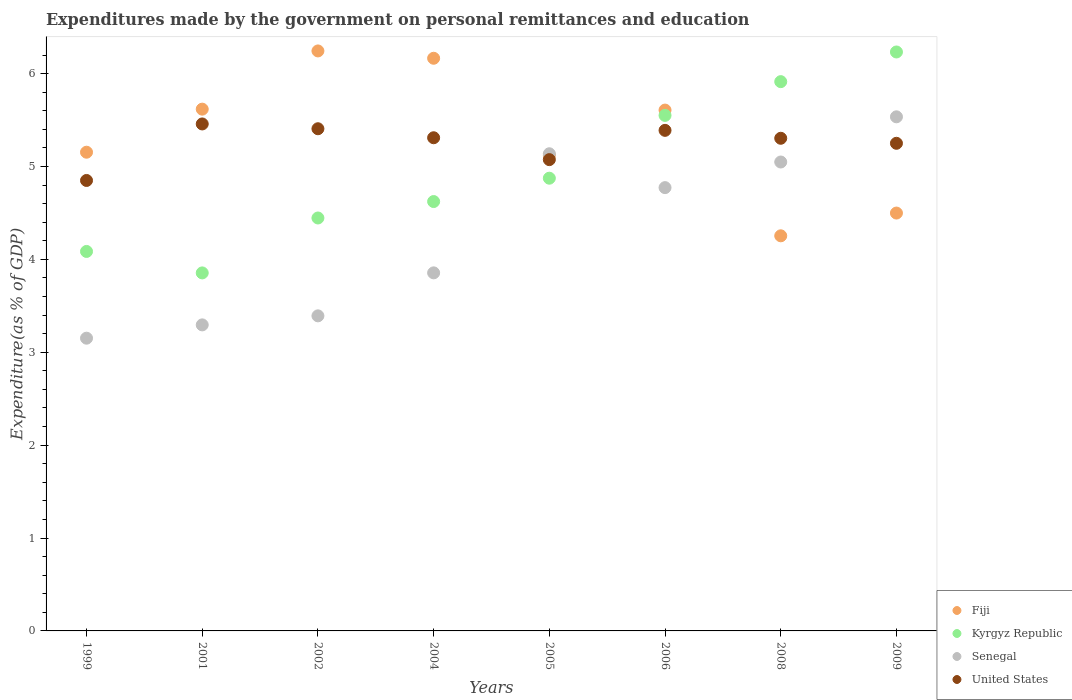What is the expenditures made by the government on personal remittances and education in Senegal in 2005?
Keep it short and to the point. 5.14. Across all years, what is the maximum expenditures made by the government on personal remittances and education in Fiji?
Provide a short and direct response. 6.24. Across all years, what is the minimum expenditures made by the government on personal remittances and education in Fiji?
Offer a terse response. 4.25. In which year was the expenditures made by the government on personal remittances and education in Fiji maximum?
Offer a very short reply. 2002. In which year was the expenditures made by the government on personal remittances and education in United States minimum?
Your answer should be compact. 1999. What is the total expenditures made by the government on personal remittances and education in Kyrgyz Republic in the graph?
Ensure brevity in your answer.  39.58. What is the difference between the expenditures made by the government on personal remittances and education in Senegal in 2004 and that in 2005?
Offer a terse response. -1.28. What is the difference between the expenditures made by the government on personal remittances and education in Senegal in 2002 and the expenditures made by the government on personal remittances and education in Fiji in 2008?
Provide a short and direct response. -0.86. What is the average expenditures made by the government on personal remittances and education in Senegal per year?
Your answer should be compact. 4.27. In the year 2008, what is the difference between the expenditures made by the government on personal remittances and education in Kyrgyz Republic and expenditures made by the government on personal remittances and education in United States?
Offer a very short reply. 0.61. What is the ratio of the expenditures made by the government on personal remittances and education in Senegal in 2001 to that in 2005?
Offer a terse response. 0.64. Is the expenditures made by the government on personal remittances and education in Kyrgyz Republic in 2004 less than that in 2005?
Make the answer very short. Yes. Is the difference between the expenditures made by the government on personal remittances and education in Kyrgyz Republic in 2001 and 2008 greater than the difference between the expenditures made by the government on personal remittances and education in United States in 2001 and 2008?
Provide a short and direct response. No. What is the difference between the highest and the second highest expenditures made by the government on personal remittances and education in Fiji?
Ensure brevity in your answer.  0.08. What is the difference between the highest and the lowest expenditures made by the government on personal remittances and education in Senegal?
Offer a very short reply. 2.38. Is it the case that in every year, the sum of the expenditures made by the government on personal remittances and education in United States and expenditures made by the government on personal remittances and education in Fiji  is greater than the sum of expenditures made by the government on personal remittances and education in Kyrgyz Republic and expenditures made by the government on personal remittances and education in Senegal?
Ensure brevity in your answer.  No. Is it the case that in every year, the sum of the expenditures made by the government on personal remittances and education in Fiji and expenditures made by the government on personal remittances and education in Senegal  is greater than the expenditures made by the government on personal remittances and education in Kyrgyz Republic?
Provide a short and direct response. Yes. Does the expenditures made by the government on personal remittances and education in United States monotonically increase over the years?
Make the answer very short. No. Is the expenditures made by the government on personal remittances and education in Kyrgyz Republic strictly greater than the expenditures made by the government on personal remittances and education in United States over the years?
Your response must be concise. No. Is the expenditures made by the government on personal remittances and education in Senegal strictly less than the expenditures made by the government on personal remittances and education in Fiji over the years?
Provide a succinct answer. No. Are the values on the major ticks of Y-axis written in scientific E-notation?
Provide a succinct answer. No. Does the graph contain any zero values?
Make the answer very short. No. Does the graph contain grids?
Your answer should be very brief. No. What is the title of the graph?
Ensure brevity in your answer.  Expenditures made by the government on personal remittances and education. What is the label or title of the Y-axis?
Provide a succinct answer. Expenditure(as % of GDP). What is the Expenditure(as % of GDP) of Fiji in 1999?
Keep it short and to the point. 5.15. What is the Expenditure(as % of GDP) in Kyrgyz Republic in 1999?
Your answer should be very brief. 4.09. What is the Expenditure(as % of GDP) in Senegal in 1999?
Ensure brevity in your answer.  3.15. What is the Expenditure(as % of GDP) of United States in 1999?
Offer a very short reply. 4.85. What is the Expenditure(as % of GDP) in Fiji in 2001?
Your answer should be compact. 5.62. What is the Expenditure(as % of GDP) in Kyrgyz Republic in 2001?
Provide a succinct answer. 3.85. What is the Expenditure(as % of GDP) of Senegal in 2001?
Provide a short and direct response. 3.29. What is the Expenditure(as % of GDP) of United States in 2001?
Keep it short and to the point. 5.46. What is the Expenditure(as % of GDP) in Fiji in 2002?
Ensure brevity in your answer.  6.24. What is the Expenditure(as % of GDP) in Kyrgyz Republic in 2002?
Your answer should be very brief. 4.45. What is the Expenditure(as % of GDP) in Senegal in 2002?
Provide a succinct answer. 3.39. What is the Expenditure(as % of GDP) in United States in 2002?
Provide a succinct answer. 5.41. What is the Expenditure(as % of GDP) of Fiji in 2004?
Offer a very short reply. 6.16. What is the Expenditure(as % of GDP) in Kyrgyz Republic in 2004?
Offer a terse response. 4.62. What is the Expenditure(as % of GDP) in Senegal in 2004?
Make the answer very short. 3.85. What is the Expenditure(as % of GDP) in United States in 2004?
Offer a very short reply. 5.31. What is the Expenditure(as % of GDP) in Fiji in 2005?
Provide a succinct answer. 5.12. What is the Expenditure(as % of GDP) in Kyrgyz Republic in 2005?
Your answer should be very brief. 4.87. What is the Expenditure(as % of GDP) in Senegal in 2005?
Provide a short and direct response. 5.14. What is the Expenditure(as % of GDP) of United States in 2005?
Offer a very short reply. 5.07. What is the Expenditure(as % of GDP) of Fiji in 2006?
Offer a terse response. 5.61. What is the Expenditure(as % of GDP) in Kyrgyz Republic in 2006?
Your response must be concise. 5.55. What is the Expenditure(as % of GDP) in Senegal in 2006?
Keep it short and to the point. 4.77. What is the Expenditure(as % of GDP) in United States in 2006?
Offer a terse response. 5.39. What is the Expenditure(as % of GDP) in Fiji in 2008?
Give a very brief answer. 4.25. What is the Expenditure(as % of GDP) in Kyrgyz Republic in 2008?
Offer a very short reply. 5.91. What is the Expenditure(as % of GDP) in Senegal in 2008?
Provide a short and direct response. 5.05. What is the Expenditure(as % of GDP) of United States in 2008?
Keep it short and to the point. 5.3. What is the Expenditure(as % of GDP) of Fiji in 2009?
Provide a short and direct response. 4.5. What is the Expenditure(as % of GDP) in Kyrgyz Republic in 2009?
Keep it short and to the point. 6.23. What is the Expenditure(as % of GDP) of Senegal in 2009?
Offer a terse response. 5.53. What is the Expenditure(as % of GDP) of United States in 2009?
Your answer should be very brief. 5.25. Across all years, what is the maximum Expenditure(as % of GDP) in Fiji?
Provide a short and direct response. 6.24. Across all years, what is the maximum Expenditure(as % of GDP) in Kyrgyz Republic?
Keep it short and to the point. 6.23. Across all years, what is the maximum Expenditure(as % of GDP) in Senegal?
Keep it short and to the point. 5.53. Across all years, what is the maximum Expenditure(as % of GDP) in United States?
Offer a terse response. 5.46. Across all years, what is the minimum Expenditure(as % of GDP) in Fiji?
Offer a very short reply. 4.25. Across all years, what is the minimum Expenditure(as % of GDP) in Kyrgyz Republic?
Your response must be concise. 3.85. Across all years, what is the minimum Expenditure(as % of GDP) of Senegal?
Provide a succinct answer. 3.15. Across all years, what is the minimum Expenditure(as % of GDP) in United States?
Provide a succinct answer. 4.85. What is the total Expenditure(as % of GDP) in Fiji in the graph?
Provide a succinct answer. 42.66. What is the total Expenditure(as % of GDP) in Kyrgyz Republic in the graph?
Your answer should be very brief. 39.58. What is the total Expenditure(as % of GDP) of Senegal in the graph?
Your response must be concise. 34.18. What is the total Expenditure(as % of GDP) in United States in the graph?
Provide a succinct answer. 42.04. What is the difference between the Expenditure(as % of GDP) in Fiji in 1999 and that in 2001?
Your answer should be compact. -0.46. What is the difference between the Expenditure(as % of GDP) in Kyrgyz Republic in 1999 and that in 2001?
Provide a short and direct response. 0.23. What is the difference between the Expenditure(as % of GDP) of Senegal in 1999 and that in 2001?
Your answer should be compact. -0.14. What is the difference between the Expenditure(as % of GDP) in United States in 1999 and that in 2001?
Give a very brief answer. -0.61. What is the difference between the Expenditure(as % of GDP) of Fiji in 1999 and that in 2002?
Your response must be concise. -1.09. What is the difference between the Expenditure(as % of GDP) of Kyrgyz Republic in 1999 and that in 2002?
Give a very brief answer. -0.36. What is the difference between the Expenditure(as % of GDP) of Senegal in 1999 and that in 2002?
Your response must be concise. -0.24. What is the difference between the Expenditure(as % of GDP) of United States in 1999 and that in 2002?
Ensure brevity in your answer.  -0.56. What is the difference between the Expenditure(as % of GDP) in Fiji in 1999 and that in 2004?
Keep it short and to the point. -1.01. What is the difference between the Expenditure(as % of GDP) in Kyrgyz Republic in 1999 and that in 2004?
Make the answer very short. -0.54. What is the difference between the Expenditure(as % of GDP) of Senegal in 1999 and that in 2004?
Make the answer very short. -0.7. What is the difference between the Expenditure(as % of GDP) of United States in 1999 and that in 2004?
Your answer should be compact. -0.46. What is the difference between the Expenditure(as % of GDP) of Fiji in 1999 and that in 2005?
Provide a succinct answer. 0.03. What is the difference between the Expenditure(as % of GDP) of Kyrgyz Republic in 1999 and that in 2005?
Offer a very short reply. -0.79. What is the difference between the Expenditure(as % of GDP) of Senegal in 1999 and that in 2005?
Provide a short and direct response. -1.99. What is the difference between the Expenditure(as % of GDP) in United States in 1999 and that in 2005?
Your response must be concise. -0.22. What is the difference between the Expenditure(as % of GDP) in Fiji in 1999 and that in 2006?
Your answer should be very brief. -0.45. What is the difference between the Expenditure(as % of GDP) in Kyrgyz Republic in 1999 and that in 2006?
Make the answer very short. -1.46. What is the difference between the Expenditure(as % of GDP) of Senegal in 1999 and that in 2006?
Keep it short and to the point. -1.62. What is the difference between the Expenditure(as % of GDP) of United States in 1999 and that in 2006?
Make the answer very short. -0.54. What is the difference between the Expenditure(as % of GDP) in Fiji in 1999 and that in 2008?
Offer a terse response. 0.9. What is the difference between the Expenditure(as % of GDP) in Kyrgyz Republic in 1999 and that in 2008?
Ensure brevity in your answer.  -1.83. What is the difference between the Expenditure(as % of GDP) of Senegal in 1999 and that in 2008?
Provide a short and direct response. -1.9. What is the difference between the Expenditure(as % of GDP) in United States in 1999 and that in 2008?
Your answer should be very brief. -0.45. What is the difference between the Expenditure(as % of GDP) in Fiji in 1999 and that in 2009?
Ensure brevity in your answer.  0.66. What is the difference between the Expenditure(as % of GDP) in Kyrgyz Republic in 1999 and that in 2009?
Make the answer very short. -2.15. What is the difference between the Expenditure(as % of GDP) in Senegal in 1999 and that in 2009?
Provide a short and direct response. -2.38. What is the difference between the Expenditure(as % of GDP) of United States in 1999 and that in 2009?
Offer a terse response. -0.4. What is the difference between the Expenditure(as % of GDP) in Fiji in 2001 and that in 2002?
Your answer should be compact. -0.63. What is the difference between the Expenditure(as % of GDP) in Kyrgyz Republic in 2001 and that in 2002?
Keep it short and to the point. -0.59. What is the difference between the Expenditure(as % of GDP) of Senegal in 2001 and that in 2002?
Keep it short and to the point. -0.1. What is the difference between the Expenditure(as % of GDP) in United States in 2001 and that in 2002?
Keep it short and to the point. 0.05. What is the difference between the Expenditure(as % of GDP) in Fiji in 2001 and that in 2004?
Provide a short and direct response. -0.55. What is the difference between the Expenditure(as % of GDP) in Kyrgyz Republic in 2001 and that in 2004?
Provide a short and direct response. -0.77. What is the difference between the Expenditure(as % of GDP) of Senegal in 2001 and that in 2004?
Your response must be concise. -0.56. What is the difference between the Expenditure(as % of GDP) of United States in 2001 and that in 2004?
Make the answer very short. 0.15. What is the difference between the Expenditure(as % of GDP) in Fiji in 2001 and that in 2005?
Provide a short and direct response. 0.5. What is the difference between the Expenditure(as % of GDP) of Kyrgyz Republic in 2001 and that in 2005?
Your answer should be compact. -1.02. What is the difference between the Expenditure(as % of GDP) in Senegal in 2001 and that in 2005?
Offer a terse response. -1.84. What is the difference between the Expenditure(as % of GDP) of United States in 2001 and that in 2005?
Your response must be concise. 0.38. What is the difference between the Expenditure(as % of GDP) in Kyrgyz Republic in 2001 and that in 2006?
Provide a short and direct response. -1.7. What is the difference between the Expenditure(as % of GDP) in Senegal in 2001 and that in 2006?
Your response must be concise. -1.48. What is the difference between the Expenditure(as % of GDP) in United States in 2001 and that in 2006?
Ensure brevity in your answer.  0.07. What is the difference between the Expenditure(as % of GDP) of Fiji in 2001 and that in 2008?
Your answer should be compact. 1.36. What is the difference between the Expenditure(as % of GDP) in Kyrgyz Republic in 2001 and that in 2008?
Your answer should be very brief. -2.06. What is the difference between the Expenditure(as % of GDP) of Senegal in 2001 and that in 2008?
Give a very brief answer. -1.75. What is the difference between the Expenditure(as % of GDP) in United States in 2001 and that in 2008?
Make the answer very short. 0.15. What is the difference between the Expenditure(as % of GDP) of Fiji in 2001 and that in 2009?
Keep it short and to the point. 1.12. What is the difference between the Expenditure(as % of GDP) in Kyrgyz Republic in 2001 and that in 2009?
Your response must be concise. -2.38. What is the difference between the Expenditure(as % of GDP) in Senegal in 2001 and that in 2009?
Keep it short and to the point. -2.24. What is the difference between the Expenditure(as % of GDP) in United States in 2001 and that in 2009?
Offer a very short reply. 0.21. What is the difference between the Expenditure(as % of GDP) in Fiji in 2002 and that in 2004?
Make the answer very short. 0.08. What is the difference between the Expenditure(as % of GDP) in Kyrgyz Republic in 2002 and that in 2004?
Offer a very short reply. -0.18. What is the difference between the Expenditure(as % of GDP) in Senegal in 2002 and that in 2004?
Your answer should be compact. -0.46. What is the difference between the Expenditure(as % of GDP) in United States in 2002 and that in 2004?
Offer a terse response. 0.1. What is the difference between the Expenditure(as % of GDP) of Fiji in 2002 and that in 2005?
Make the answer very short. 1.12. What is the difference between the Expenditure(as % of GDP) in Kyrgyz Republic in 2002 and that in 2005?
Offer a very short reply. -0.43. What is the difference between the Expenditure(as % of GDP) in Senegal in 2002 and that in 2005?
Keep it short and to the point. -1.75. What is the difference between the Expenditure(as % of GDP) of United States in 2002 and that in 2005?
Give a very brief answer. 0.33. What is the difference between the Expenditure(as % of GDP) in Fiji in 2002 and that in 2006?
Give a very brief answer. 0.64. What is the difference between the Expenditure(as % of GDP) of Kyrgyz Republic in 2002 and that in 2006?
Keep it short and to the point. -1.1. What is the difference between the Expenditure(as % of GDP) of Senegal in 2002 and that in 2006?
Your answer should be very brief. -1.38. What is the difference between the Expenditure(as % of GDP) of United States in 2002 and that in 2006?
Your answer should be very brief. 0.02. What is the difference between the Expenditure(as % of GDP) in Fiji in 2002 and that in 2008?
Give a very brief answer. 1.99. What is the difference between the Expenditure(as % of GDP) of Kyrgyz Republic in 2002 and that in 2008?
Your answer should be compact. -1.47. What is the difference between the Expenditure(as % of GDP) of Senegal in 2002 and that in 2008?
Make the answer very short. -1.66. What is the difference between the Expenditure(as % of GDP) in United States in 2002 and that in 2008?
Keep it short and to the point. 0.1. What is the difference between the Expenditure(as % of GDP) in Fiji in 2002 and that in 2009?
Keep it short and to the point. 1.75. What is the difference between the Expenditure(as % of GDP) of Kyrgyz Republic in 2002 and that in 2009?
Offer a very short reply. -1.79. What is the difference between the Expenditure(as % of GDP) in Senegal in 2002 and that in 2009?
Provide a succinct answer. -2.14. What is the difference between the Expenditure(as % of GDP) of United States in 2002 and that in 2009?
Give a very brief answer. 0.16. What is the difference between the Expenditure(as % of GDP) in Fiji in 2004 and that in 2005?
Provide a succinct answer. 1.04. What is the difference between the Expenditure(as % of GDP) in Kyrgyz Republic in 2004 and that in 2005?
Make the answer very short. -0.25. What is the difference between the Expenditure(as % of GDP) in Senegal in 2004 and that in 2005?
Ensure brevity in your answer.  -1.28. What is the difference between the Expenditure(as % of GDP) in United States in 2004 and that in 2005?
Offer a very short reply. 0.24. What is the difference between the Expenditure(as % of GDP) in Fiji in 2004 and that in 2006?
Your response must be concise. 0.56. What is the difference between the Expenditure(as % of GDP) in Kyrgyz Republic in 2004 and that in 2006?
Make the answer very short. -0.93. What is the difference between the Expenditure(as % of GDP) in Senegal in 2004 and that in 2006?
Give a very brief answer. -0.92. What is the difference between the Expenditure(as % of GDP) in United States in 2004 and that in 2006?
Your response must be concise. -0.08. What is the difference between the Expenditure(as % of GDP) in Fiji in 2004 and that in 2008?
Ensure brevity in your answer.  1.91. What is the difference between the Expenditure(as % of GDP) in Kyrgyz Republic in 2004 and that in 2008?
Ensure brevity in your answer.  -1.29. What is the difference between the Expenditure(as % of GDP) of Senegal in 2004 and that in 2008?
Your response must be concise. -1.19. What is the difference between the Expenditure(as % of GDP) in United States in 2004 and that in 2008?
Make the answer very short. 0.01. What is the difference between the Expenditure(as % of GDP) in Fiji in 2004 and that in 2009?
Provide a succinct answer. 1.67. What is the difference between the Expenditure(as % of GDP) of Kyrgyz Republic in 2004 and that in 2009?
Provide a succinct answer. -1.61. What is the difference between the Expenditure(as % of GDP) of Senegal in 2004 and that in 2009?
Your answer should be very brief. -1.68. What is the difference between the Expenditure(as % of GDP) in United States in 2004 and that in 2009?
Your answer should be compact. 0.06. What is the difference between the Expenditure(as % of GDP) in Fiji in 2005 and that in 2006?
Offer a very short reply. -0.49. What is the difference between the Expenditure(as % of GDP) in Kyrgyz Republic in 2005 and that in 2006?
Ensure brevity in your answer.  -0.68. What is the difference between the Expenditure(as % of GDP) of Senegal in 2005 and that in 2006?
Ensure brevity in your answer.  0.36. What is the difference between the Expenditure(as % of GDP) of United States in 2005 and that in 2006?
Ensure brevity in your answer.  -0.32. What is the difference between the Expenditure(as % of GDP) of Fiji in 2005 and that in 2008?
Your answer should be very brief. 0.87. What is the difference between the Expenditure(as % of GDP) of Kyrgyz Republic in 2005 and that in 2008?
Your answer should be compact. -1.04. What is the difference between the Expenditure(as % of GDP) of Senegal in 2005 and that in 2008?
Keep it short and to the point. 0.09. What is the difference between the Expenditure(as % of GDP) of United States in 2005 and that in 2008?
Provide a succinct answer. -0.23. What is the difference between the Expenditure(as % of GDP) of Fiji in 2005 and that in 2009?
Your answer should be compact. 0.62. What is the difference between the Expenditure(as % of GDP) of Kyrgyz Republic in 2005 and that in 2009?
Your response must be concise. -1.36. What is the difference between the Expenditure(as % of GDP) of Senegal in 2005 and that in 2009?
Offer a terse response. -0.4. What is the difference between the Expenditure(as % of GDP) of United States in 2005 and that in 2009?
Your answer should be compact. -0.18. What is the difference between the Expenditure(as % of GDP) in Fiji in 2006 and that in 2008?
Your response must be concise. 1.35. What is the difference between the Expenditure(as % of GDP) in Kyrgyz Republic in 2006 and that in 2008?
Make the answer very short. -0.36. What is the difference between the Expenditure(as % of GDP) in Senegal in 2006 and that in 2008?
Make the answer very short. -0.28. What is the difference between the Expenditure(as % of GDP) in United States in 2006 and that in 2008?
Give a very brief answer. 0.09. What is the difference between the Expenditure(as % of GDP) of Fiji in 2006 and that in 2009?
Offer a terse response. 1.11. What is the difference between the Expenditure(as % of GDP) in Kyrgyz Republic in 2006 and that in 2009?
Your answer should be compact. -0.68. What is the difference between the Expenditure(as % of GDP) in Senegal in 2006 and that in 2009?
Offer a very short reply. -0.76. What is the difference between the Expenditure(as % of GDP) in United States in 2006 and that in 2009?
Make the answer very short. 0.14. What is the difference between the Expenditure(as % of GDP) in Fiji in 2008 and that in 2009?
Your answer should be compact. -0.24. What is the difference between the Expenditure(as % of GDP) of Kyrgyz Republic in 2008 and that in 2009?
Your response must be concise. -0.32. What is the difference between the Expenditure(as % of GDP) of Senegal in 2008 and that in 2009?
Make the answer very short. -0.49. What is the difference between the Expenditure(as % of GDP) of United States in 2008 and that in 2009?
Make the answer very short. 0.05. What is the difference between the Expenditure(as % of GDP) in Fiji in 1999 and the Expenditure(as % of GDP) in Kyrgyz Republic in 2001?
Make the answer very short. 1.3. What is the difference between the Expenditure(as % of GDP) in Fiji in 1999 and the Expenditure(as % of GDP) in Senegal in 2001?
Give a very brief answer. 1.86. What is the difference between the Expenditure(as % of GDP) in Fiji in 1999 and the Expenditure(as % of GDP) in United States in 2001?
Keep it short and to the point. -0.3. What is the difference between the Expenditure(as % of GDP) in Kyrgyz Republic in 1999 and the Expenditure(as % of GDP) in Senegal in 2001?
Your answer should be very brief. 0.79. What is the difference between the Expenditure(as % of GDP) of Kyrgyz Republic in 1999 and the Expenditure(as % of GDP) of United States in 2001?
Make the answer very short. -1.37. What is the difference between the Expenditure(as % of GDP) in Senegal in 1999 and the Expenditure(as % of GDP) in United States in 2001?
Ensure brevity in your answer.  -2.31. What is the difference between the Expenditure(as % of GDP) of Fiji in 1999 and the Expenditure(as % of GDP) of Kyrgyz Republic in 2002?
Ensure brevity in your answer.  0.71. What is the difference between the Expenditure(as % of GDP) of Fiji in 1999 and the Expenditure(as % of GDP) of Senegal in 2002?
Keep it short and to the point. 1.76. What is the difference between the Expenditure(as % of GDP) of Fiji in 1999 and the Expenditure(as % of GDP) of United States in 2002?
Your answer should be very brief. -0.25. What is the difference between the Expenditure(as % of GDP) of Kyrgyz Republic in 1999 and the Expenditure(as % of GDP) of Senegal in 2002?
Offer a terse response. 0.69. What is the difference between the Expenditure(as % of GDP) in Kyrgyz Republic in 1999 and the Expenditure(as % of GDP) in United States in 2002?
Ensure brevity in your answer.  -1.32. What is the difference between the Expenditure(as % of GDP) of Senegal in 1999 and the Expenditure(as % of GDP) of United States in 2002?
Make the answer very short. -2.25. What is the difference between the Expenditure(as % of GDP) of Fiji in 1999 and the Expenditure(as % of GDP) of Kyrgyz Republic in 2004?
Your answer should be compact. 0.53. What is the difference between the Expenditure(as % of GDP) of Fiji in 1999 and the Expenditure(as % of GDP) of Senegal in 2004?
Your answer should be very brief. 1.3. What is the difference between the Expenditure(as % of GDP) in Fiji in 1999 and the Expenditure(as % of GDP) in United States in 2004?
Make the answer very short. -0.16. What is the difference between the Expenditure(as % of GDP) in Kyrgyz Republic in 1999 and the Expenditure(as % of GDP) in Senegal in 2004?
Offer a terse response. 0.23. What is the difference between the Expenditure(as % of GDP) of Kyrgyz Republic in 1999 and the Expenditure(as % of GDP) of United States in 2004?
Ensure brevity in your answer.  -1.22. What is the difference between the Expenditure(as % of GDP) in Senegal in 1999 and the Expenditure(as % of GDP) in United States in 2004?
Give a very brief answer. -2.16. What is the difference between the Expenditure(as % of GDP) of Fiji in 1999 and the Expenditure(as % of GDP) of Kyrgyz Republic in 2005?
Make the answer very short. 0.28. What is the difference between the Expenditure(as % of GDP) in Fiji in 1999 and the Expenditure(as % of GDP) in Senegal in 2005?
Your response must be concise. 0.02. What is the difference between the Expenditure(as % of GDP) in Fiji in 1999 and the Expenditure(as % of GDP) in United States in 2005?
Offer a very short reply. 0.08. What is the difference between the Expenditure(as % of GDP) in Kyrgyz Republic in 1999 and the Expenditure(as % of GDP) in Senegal in 2005?
Offer a very short reply. -1.05. What is the difference between the Expenditure(as % of GDP) of Kyrgyz Republic in 1999 and the Expenditure(as % of GDP) of United States in 2005?
Offer a very short reply. -0.99. What is the difference between the Expenditure(as % of GDP) in Senegal in 1999 and the Expenditure(as % of GDP) in United States in 2005?
Keep it short and to the point. -1.92. What is the difference between the Expenditure(as % of GDP) of Fiji in 1999 and the Expenditure(as % of GDP) of Kyrgyz Republic in 2006?
Offer a very short reply. -0.4. What is the difference between the Expenditure(as % of GDP) of Fiji in 1999 and the Expenditure(as % of GDP) of Senegal in 2006?
Make the answer very short. 0.38. What is the difference between the Expenditure(as % of GDP) of Fiji in 1999 and the Expenditure(as % of GDP) of United States in 2006?
Offer a very short reply. -0.24. What is the difference between the Expenditure(as % of GDP) of Kyrgyz Republic in 1999 and the Expenditure(as % of GDP) of Senegal in 2006?
Make the answer very short. -0.69. What is the difference between the Expenditure(as % of GDP) in Kyrgyz Republic in 1999 and the Expenditure(as % of GDP) in United States in 2006?
Give a very brief answer. -1.3. What is the difference between the Expenditure(as % of GDP) of Senegal in 1999 and the Expenditure(as % of GDP) of United States in 2006?
Ensure brevity in your answer.  -2.24. What is the difference between the Expenditure(as % of GDP) of Fiji in 1999 and the Expenditure(as % of GDP) of Kyrgyz Republic in 2008?
Keep it short and to the point. -0.76. What is the difference between the Expenditure(as % of GDP) of Fiji in 1999 and the Expenditure(as % of GDP) of Senegal in 2008?
Your answer should be very brief. 0.11. What is the difference between the Expenditure(as % of GDP) of Fiji in 1999 and the Expenditure(as % of GDP) of United States in 2008?
Your answer should be very brief. -0.15. What is the difference between the Expenditure(as % of GDP) of Kyrgyz Republic in 1999 and the Expenditure(as % of GDP) of Senegal in 2008?
Provide a succinct answer. -0.96. What is the difference between the Expenditure(as % of GDP) of Kyrgyz Republic in 1999 and the Expenditure(as % of GDP) of United States in 2008?
Ensure brevity in your answer.  -1.22. What is the difference between the Expenditure(as % of GDP) in Senegal in 1999 and the Expenditure(as % of GDP) in United States in 2008?
Make the answer very short. -2.15. What is the difference between the Expenditure(as % of GDP) in Fiji in 1999 and the Expenditure(as % of GDP) in Kyrgyz Republic in 2009?
Offer a very short reply. -1.08. What is the difference between the Expenditure(as % of GDP) of Fiji in 1999 and the Expenditure(as % of GDP) of Senegal in 2009?
Provide a short and direct response. -0.38. What is the difference between the Expenditure(as % of GDP) in Fiji in 1999 and the Expenditure(as % of GDP) in United States in 2009?
Ensure brevity in your answer.  -0.1. What is the difference between the Expenditure(as % of GDP) in Kyrgyz Republic in 1999 and the Expenditure(as % of GDP) in Senegal in 2009?
Your answer should be very brief. -1.45. What is the difference between the Expenditure(as % of GDP) of Kyrgyz Republic in 1999 and the Expenditure(as % of GDP) of United States in 2009?
Keep it short and to the point. -1.16. What is the difference between the Expenditure(as % of GDP) of Senegal in 1999 and the Expenditure(as % of GDP) of United States in 2009?
Provide a succinct answer. -2.1. What is the difference between the Expenditure(as % of GDP) of Fiji in 2001 and the Expenditure(as % of GDP) of Kyrgyz Republic in 2002?
Your answer should be compact. 1.17. What is the difference between the Expenditure(as % of GDP) of Fiji in 2001 and the Expenditure(as % of GDP) of Senegal in 2002?
Provide a short and direct response. 2.23. What is the difference between the Expenditure(as % of GDP) in Fiji in 2001 and the Expenditure(as % of GDP) in United States in 2002?
Provide a succinct answer. 0.21. What is the difference between the Expenditure(as % of GDP) of Kyrgyz Republic in 2001 and the Expenditure(as % of GDP) of Senegal in 2002?
Keep it short and to the point. 0.46. What is the difference between the Expenditure(as % of GDP) of Kyrgyz Republic in 2001 and the Expenditure(as % of GDP) of United States in 2002?
Your response must be concise. -1.55. What is the difference between the Expenditure(as % of GDP) in Senegal in 2001 and the Expenditure(as % of GDP) in United States in 2002?
Offer a terse response. -2.11. What is the difference between the Expenditure(as % of GDP) in Fiji in 2001 and the Expenditure(as % of GDP) in Kyrgyz Republic in 2004?
Give a very brief answer. 0.99. What is the difference between the Expenditure(as % of GDP) of Fiji in 2001 and the Expenditure(as % of GDP) of Senegal in 2004?
Your answer should be compact. 1.76. What is the difference between the Expenditure(as % of GDP) in Fiji in 2001 and the Expenditure(as % of GDP) in United States in 2004?
Make the answer very short. 0.31. What is the difference between the Expenditure(as % of GDP) of Kyrgyz Republic in 2001 and the Expenditure(as % of GDP) of Senegal in 2004?
Your answer should be very brief. -0. What is the difference between the Expenditure(as % of GDP) of Kyrgyz Republic in 2001 and the Expenditure(as % of GDP) of United States in 2004?
Make the answer very short. -1.46. What is the difference between the Expenditure(as % of GDP) in Senegal in 2001 and the Expenditure(as % of GDP) in United States in 2004?
Make the answer very short. -2.01. What is the difference between the Expenditure(as % of GDP) in Fiji in 2001 and the Expenditure(as % of GDP) in Kyrgyz Republic in 2005?
Give a very brief answer. 0.74. What is the difference between the Expenditure(as % of GDP) of Fiji in 2001 and the Expenditure(as % of GDP) of Senegal in 2005?
Provide a succinct answer. 0.48. What is the difference between the Expenditure(as % of GDP) in Fiji in 2001 and the Expenditure(as % of GDP) in United States in 2005?
Your response must be concise. 0.54. What is the difference between the Expenditure(as % of GDP) in Kyrgyz Republic in 2001 and the Expenditure(as % of GDP) in Senegal in 2005?
Keep it short and to the point. -1.28. What is the difference between the Expenditure(as % of GDP) of Kyrgyz Republic in 2001 and the Expenditure(as % of GDP) of United States in 2005?
Ensure brevity in your answer.  -1.22. What is the difference between the Expenditure(as % of GDP) of Senegal in 2001 and the Expenditure(as % of GDP) of United States in 2005?
Give a very brief answer. -1.78. What is the difference between the Expenditure(as % of GDP) of Fiji in 2001 and the Expenditure(as % of GDP) of Kyrgyz Republic in 2006?
Provide a short and direct response. 0.07. What is the difference between the Expenditure(as % of GDP) in Fiji in 2001 and the Expenditure(as % of GDP) in Senegal in 2006?
Offer a very short reply. 0.84. What is the difference between the Expenditure(as % of GDP) in Fiji in 2001 and the Expenditure(as % of GDP) in United States in 2006?
Offer a very short reply. 0.23. What is the difference between the Expenditure(as % of GDP) of Kyrgyz Republic in 2001 and the Expenditure(as % of GDP) of Senegal in 2006?
Give a very brief answer. -0.92. What is the difference between the Expenditure(as % of GDP) of Kyrgyz Republic in 2001 and the Expenditure(as % of GDP) of United States in 2006?
Keep it short and to the point. -1.53. What is the difference between the Expenditure(as % of GDP) in Senegal in 2001 and the Expenditure(as % of GDP) in United States in 2006?
Keep it short and to the point. -2.09. What is the difference between the Expenditure(as % of GDP) of Fiji in 2001 and the Expenditure(as % of GDP) of Kyrgyz Republic in 2008?
Ensure brevity in your answer.  -0.3. What is the difference between the Expenditure(as % of GDP) of Fiji in 2001 and the Expenditure(as % of GDP) of Senegal in 2008?
Provide a succinct answer. 0.57. What is the difference between the Expenditure(as % of GDP) in Fiji in 2001 and the Expenditure(as % of GDP) in United States in 2008?
Offer a very short reply. 0.31. What is the difference between the Expenditure(as % of GDP) of Kyrgyz Republic in 2001 and the Expenditure(as % of GDP) of Senegal in 2008?
Make the answer very short. -1.19. What is the difference between the Expenditure(as % of GDP) in Kyrgyz Republic in 2001 and the Expenditure(as % of GDP) in United States in 2008?
Make the answer very short. -1.45. What is the difference between the Expenditure(as % of GDP) of Senegal in 2001 and the Expenditure(as % of GDP) of United States in 2008?
Keep it short and to the point. -2.01. What is the difference between the Expenditure(as % of GDP) of Fiji in 2001 and the Expenditure(as % of GDP) of Kyrgyz Republic in 2009?
Make the answer very short. -0.62. What is the difference between the Expenditure(as % of GDP) in Fiji in 2001 and the Expenditure(as % of GDP) in Senegal in 2009?
Your response must be concise. 0.08. What is the difference between the Expenditure(as % of GDP) in Fiji in 2001 and the Expenditure(as % of GDP) in United States in 2009?
Ensure brevity in your answer.  0.37. What is the difference between the Expenditure(as % of GDP) of Kyrgyz Republic in 2001 and the Expenditure(as % of GDP) of Senegal in 2009?
Your answer should be compact. -1.68. What is the difference between the Expenditure(as % of GDP) in Kyrgyz Republic in 2001 and the Expenditure(as % of GDP) in United States in 2009?
Make the answer very short. -1.4. What is the difference between the Expenditure(as % of GDP) in Senegal in 2001 and the Expenditure(as % of GDP) in United States in 2009?
Give a very brief answer. -1.95. What is the difference between the Expenditure(as % of GDP) of Fiji in 2002 and the Expenditure(as % of GDP) of Kyrgyz Republic in 2004?
Give a very brief answer. 1.62. What is the difference between the Expenditure(as % of GDP) of Fiji in 2002 and the Expenditure(as % of GDP) of Senegal in 2004?
Your answer should be very brief. 2.39. What is the difference between the Expenditure(as % of GDP) of Fiji in 2002 and the Expenditure(as % of GDP) of United States in 2004?
Make the answer very short. 0.93. What is the difference between the Expenditure(as % of GDP) in Kyrgyz Republic in 2002 and the Expenditure(as % of GDP) in Senegal in 2004?
Provide a succinct answer. 0.59. What is the difference between the Expenditure(as % of GDP) in Kyrgyz Republic in 2002 and the Expenditure(as % of GDP) in United States in 2004?
Your response must be concise. -0.86. What is the difference between the Expenditure(as % of GDP) of Senegal in 2002 and the Expenditure(as % of GDP) of United States in 2004?
Your answer should be very brief. -1.92. What is the difference between the Expenditure(as % of GDP) of Fiji in 2002 and the Expenditure(as % of GDP) of Kyrgyz Republic in 2005?
Keep it short and to the point. 1.37. What is the difference between the Expenditure(as % of GDP) in Fiji in 2002 and the Expenditure(as % of GDP) in Senegal in 2005?
Provide a succinct answer. 1.11. What is the difference between the Expenditure(as % of GDP) in Fiji in 2002 and the Expenditure(as % of GDP) in United States in 2005?
Offer a terse response. 1.17. What is the difference between the Expenditure(as % of GDP) in Kyrgyz Republic in 2002 and the Expenditure(as % of GDP) in Senegal in 2005?
Make the answer very short. -0.69. What is the difference between the Expenditure(as % of GDP) in Kyrgyz Republic in 2002 and the Expenditure(as % of GDP) in United States in 2005?
Your response must be concise. -0.63. What is the difference between the Expenditure(as % of GDP) in Senegal in 2002 and the Expenditure(as % of GDP) in United States in 2005?
Offer a terse response. -1.68. What is the difference between the Expenditure(as % of GDP) in Fiji in 2002 and the Expenditure(as % of GDP) in Kyrgyz Republic in 2006?
Ensure brevity in your answer.  0.69. What is the difference between the Expenditure(as % of GDP) in Fiji in 2002 and the Expenditure(as % of GDP) in Senegal in 2006?
Provide a succinct answer. 1.47. What is the difference between the Expenditure(as % of GDP) in Fiji in 2002 and the Expenditure(as % of GDP) in United States in 2006?
Offer a very short reply. 0.85. What is the difference between the Expenditure(as % of GDP) of Kyrgyz Republic in 2002 and the Expenditure(as % of GDP) of Senegal in 2006?
Offer a terse response. -0.33. What is the difference between the Expenditure(as % of GDP) of Kyrgyz Republic in 2002 and the Expenditure(as % of GDP) of United States in 2006?
Keep it short and to the point. -0.94. What is the difference between the Expenditure(as % of GDP) in Senegal in 2002 and the Expenditure(as % of GDP) in United States in 2006?
Offer a terse response. -2. What is the difference between the Expenditure(as % of GDP) in Fiji in 2002 and the Expenditure(as % of GDP) in Kyrgyz Republic in 2008?
Your answer should be very brief. 0.33. What is the difference between the Expenditure(as % of GDP) in Fiji in 2002 and the Expenditure(as % of GDP) in Senegal in 2008?
Make the answer very short. 1.2. What is the difference between the Expenditure(as % of GDP) in Fiji in 2002 and the Expenditure(as % of GDP) in United States in 2008?
Make the answer very short. 0.94. What is the difference between the Expenditure(as % of GDP) in Kyrgyz Republic in 2002 and the Expenditure(as % of GDP) in Senegal in 2008?
Ensure brevity in your answer.  -0.6. What is the difference between the Expenditure(as % of GDP) of Kyrgyz Republic in 2002 and the Expenditure(as % of GDP) of United States in 2008?
Provide a short and direct response. -0.86. What is the difference between the Expenditure(as % of GDP) in Senegal in 2002 and the Expenditure(as % of GDP) in United States in 2008?
Your response must be concise. -1.91. What is the difference between the Expenditure(as % of GDP) in Fiji in 2002 and the Expenditure(as % of GDP) in Kyrgyz Republic in 2009?
Your response must be concise. 0.01. What is the difference between the Expenditure(as % of GDP) of Fiji in 2002 and the Expenditure(as % of GDP) of Senegal in 2009?
Offer a very short reply. 0.71. What is the difference between the Expenditure(as % of GDP) of Fiji in 2002 and the Expenditure(as % of GDP) of United States in 2009?
Your answer should be compact. 0.99. What is the difference between the Expenditure(as % of GDP) in Kyrgyz Republic in 2002 and the Expenditure(as % of GDP) in Senegal in 2009?
Your response must be concise. -1.09. What is the difference between the Expenditure(as % of GDP) of Kyrgyz Republic in 2002 and the Expenditure(as % of GDP) of United States in 2009?
Offer a very short reply. -0.8. What is the difference between the Expenditure(as % of GDP) of Senegal in 2002 and the Expenditure(as % of GDP) of United States in 2009?
Provide a succinct answer. -1.86. What is the difference between the Expenditure(as % of GDP) in Fiji in 2004 and the Expenditure(as % of GDP) in Kyrgyz Republic in 2005?
Your answer should be very brief. 1.29. What is the difference between the Expenditure(as % of GDP) of Fiji in 2004 and the Expenditure(as % of GDP) of Senegal in 2005?
Keep it short and to the point. 1.03. What is the difference between the Expenditure(as % of GDP) in Fiji in 2004 and the Expenditure(as % of GDP) in United States in 2005?
Make the answer very short. 1.09. What is the difference between the Expenditure(as % of GDP) in Kyrgyz Republic in 2004 and the Expenditure(as % of GDP) in Senegal in 2005?
Make the answer very short. -0.51. What is the difference between the Expenditure(as % of GDP) in Kyrgyz Republic in 2004 and the Expenditure(as % of GDP) in United States in 2005?
Your answer should be very brief. -0.45. What is the difference between the Expenditure(as % of GDP) in Senegal in 2004 and the Expenditure(as % of GDP) in United States in 2005?
Offer a terse response. -1.22. What is the difference between the Expenditure(as % of GDP) of Fiji in 2004 and the Expenditure(as % of GDP) of Kyrgyz Republic in 2006?
Provide a succinct answer. 0.62. What is the difference between the Expenditure(as % of GDP) in Fiji in 2004 and the Expenditure(as % of GDP) in Senegal in 2006?
Offer a very short reply. 1.39. What is the difference between the Expenditure(as % of GDP) in Fiji in 2004 and the Expenditure(as % of GDP) in United States in 2006?
Your answer should be compact. 0.78. What is the difference between the Expenditure(as % of GDP) in Kyrgyz Republic in 2004 and the Expenditure(as % of GDP) in Senegal in 2006?
Your response must be concise. -0.15. What is the difference between the Expenditure(as % of GDP) in Kyrgyz Republic in 2004 and the Expenditure(as % of GDP) in United States in 2006?
Your response must be concise. -0.77. What is the difference between the Expenditure(as % of GDP) of Senegal in 2004 and the Expenditure(as % of GDP) of United States in 2006?
Provide a short and direct response. -1.53. What is the difference between the Expenditure(as % of GDP) in Fiji in 2004 and the Expenditure(as % of GDP) in Kyrgyz Republic in 2008?
Give a very brief answer. 0.25. What is the difference between the Expenditure(as % of GDP) of Fiji in 2004 and the Expenditure(as % of GDP) of Senegal in 2008?
Offer a terse response. 1.12. What is the difference between the Expenditure(as % of GDP) of Fiji in 2004 and the Expenditure(as % of GDP) of United States in 2008?
Give a very brief answer. 0.86. What is the difference between the Expenditure(as % of GDP) of Kyrgyz Republic in 2004 and the Expenditure(as % of GDP) of Senegal in 2008?
Your answer should be very brief. -0.43. What is the difference between the Expenditure(as % of GDP) in Kyrgyz Republic in 2004 and the Expenditure(as % of GDP) in United States in 2008?
Ensure brevity in your answer.  -0.68. What is the difference between the Expenditure(as % of GDP) of Senegal in 2004 and the Expenditure(as % of GDP) of United States in 2008?
Make the answer very short. -1.45. What is the difference between the Expenditure(as % of GDP) of Fiji in 2004 and the Expenditure(as % of GDP) of Kyrgyz Republic in 2009?
Your answer should be very brief. -0.07. What is the difference between the Expenditure(as % of GDP) of Fiji in 2004 and the Expenditure(as % of GDP) of Senegal in 2009?
Your answer should be compact. 0.63. What is the difference between the Expenditure(as % of GDP) in Fiji in 2004 and the Expenditure(as % of GDP) in United States in 2009?
Give a very brief answer. 0.92. What is the difference between the Expenditure(as % of GDP) in Kyrgyz Republic in 2004 and the Expenditure(as % of GDP) in Senegal in 2009?
Keep it short and to the point. -0.91. What is the difference between the Expenditure(as % of GDP) of Kyrgyz Republic in 2004 and the Expenditure(as % of GDP) of United States in 2009?
Keep it short and to the point. -0.63. What is the difference between the Expenditure(as % of GDP) of Senegal in 2004 and the Expenditure(as % of GDP) of United States in 2009?
Your answer should be very brief. -1.39. What is the difference between the Expenditure(as % of GDP) in Fiji in 2005 and the Expenditure(as % of GDP) in Kyrgyz Republic in 2006?
Offer a very short reply. -0.43. What is the difference between the Expenditure(as % of GDP) in Fiji in 2005 and the Expenditure(as % of GDP) in Senegal in 2006?
Your response must be concise. 0.35. What is the difference between the Expenditure(as % of GDP) in Fiji in 2005 and the Expenditure(as % of GDP) in United States in 2006?
Your answer should be compact. -0.27. What is the difference between the Expenditure(as % of GDP) of Kyrgyz Republic in 2005 and the Expenditure(as % of GDP) of Senegal in 2006?
Provide a short and direct response. 0.1. What is the difference between the Expenditure(as % of GDP) in Kyrgyz Republic in 2005 and the Expenditure(as % of GDP) in United States in 2006?
Your answer should be compact. -0.52. What is the difference between the Expenditure(as % of GDP) in Senegal in 2005 and the Expenditure(as % of GDP) in United States in 2006?
Provide a short and direct response. -0.25. What is the difference between the Expenditure(as % of GDP) of Fiji in 2005 and the Expenditure(as % of GDP) of Kyrgyz Republic in 2008?
Provide a succinct answer. -0.79. What is the difference between the Expenditure(as % of GDP) of Fiji in 2005 and the Expenditure(as % of GDP) of Senegal in 2008?
Your answer should be compact. 0.07. What is the difference between the Expenditure(as % of GDP) in Fiji in 2005 and the Expenditure(as % of GDP) in United States in 2008?
Ensure brevity in your answer.  -0.18. What is the difference between the Expenditure(as % of GDP) of Kyrgyz Republic in 2005 and the Expenditure(as % of GDP) of Senegal in 2008?
Provide a short and direct response. -0.17. What is the difference between the Expenditure(as % of GDP) of Kyrgyz Republic in 2005 and the Expenditure(as % of GDP) of United States in 2008?
Provide a succinct answer. -0.43. What is the difference between the Expenditure(as % of GDP) in Senegal in 2005 and the Expenditure(as % of GDP) in United States in 2008?
Offer a very short reply. -0.17. What is the difference between the Expenditure(as % of GDP) of Fiji in 2005 and the Expenditure(as % of GDP) of Kyrgyz Republic in 2009?
Give a very brief answer. -1.11. What is the difference between the Expenditure(as % of GDP) of Fiji in 2005 and the Expenditure(as % of GDP) of Senegal in 2009?
Your answer should be compact. -0.41. What is the difference between the Expenditure(as % of GDP) of Fiji in 2005 and the Expenditure(as % of GDP) of United States in 2009?
Keep it short and to the point. -0.13. What is the difference between the Expenditure(as % of GDP) in Kyrgyz Republic in 2005 and the Expenditure(as % of GDP) in Senegal in 2009?
Offer a terse response. -0.66. What is the difference between the Expenditure(as % of GDP) in Kyrgyz Republic in 2005 and the Expenditure(as % of GDP) in United States in 2009?
Your answer should be compact. -0.38. What is the difference between the Expenditure(as % of GDP) in Senegal in 2005 and the Expenditure(as % of GDP) in United States in 2009?
Make the answer very short. -0.11. What is the difference between the Expenditure(as % of GDP) in Fiji in 2006 and the Expenditure(as % of GDP) in Kyrgyz Republic in 2008?
Provide a succinct answer. -0.31. What is the difference between the Expenditure(as % of GDP) of Fiji in 2006 and the Expenditure(as % of GDP) of Senegal in 2008?
Make the answer very short. 0.56. What is the difference between the Expenditure(as % of GDP) of Fiji in 2006 and the Expenditure(as % of GDP) of United States in 2008?
Give a very brief answer. 0.3. What is the difference between the Expenditure(as % of GDP) in Kyrgyz Republic in 2006 and the Expenditure(as % of GDP) in Senegal in 2008?
Give a very brief answer. 0.5. What is the difference between the Expenditure(as % of GDP) of Kyrgyz Republic in 2006 and the Expenditure(as % of GDP) of United States in 2008?
Ensure brevity in your answer.  0.25. What is the difference between the Expenditure(as % of GDP) in Senegal in 2006 and the Expenditure(as % of GDP) in United States in 2008?
Offer a terse response. -0.53. What is the difference between the Expenditure(as % of GDP) in Fiji in 2006 and the Expenditure(as % of GDP) in Kyrgyz Republic in 2009?
Make the answer very short. -0.63. What is the difference between the Expenditure(as % of GDP) in Fiji in 2006 and the Expenditure(as % of GDP) in Senegal in 2009?
Offer a very short reply. 0.07. What is the difference between the Expenditure(as % of GDP) in Fiji in 2006 and the Expenditure(as % of GDP) in United States in 2009?
Your response must be concise. 0.36. What is the difference between the Expenditure(as % of GDP) of Kyrgyz Republic in 2006 and the Expenditure(as % of GDP) of Senegal in 2009?
Ensure brevity in your answer.  0.02. What is the difference between the Expenditure(as % of GDP) in Kyrgyz Republic in 2006 and the Expenditure(as % of GDP) in United States in 2009?
Make the answer very short. 0.3. What is the difference between the Expenditure(as % of GDP) in Senegal in 2006 and the Expenditure(as % of GDP) in United States in 2009?
Your answer should be compact. -0.48. What is the difference between the Expenditure(as % of GDP) of Fiji in 2008 and the Expenditure(as % of GDP) of Kyrgyz Republic in 2009?
Keep it short and to the point. -1.98. What is the difference between the Expenditure(as % of GDP) of Fiji in 2008 and the Expenditure(as % of GDP) of Senegal in 2009?
Your answer should be compact. -1.28. What is the difference between the Expenditure(as % of GDP) of Fiji in 2008 and the Expenditure(as % of GDP) of United States in 2009?
Offer a very short reply. -1. What is the difference between the Expenditure(as % of GDP) of Kyrgyz Republic in 2008 and the Expenditure(as % of GDP) of Senegal in 2009?
Your answer should be compact. 0.38. What is the difference between the Expenditure(as % of GDP) in Kyrgyz Republic in 2008 and the Expenditure(as % of GDP) in United States in 2009?
Provide a short and direct response. 0.66. What is the difference between the Expenditure(as % of GDP) in Senegal in 2008 and the Expenditure(as % of GDP) in United States in 2009?
Your answer should be very brief. -0.2. What is the average Expenditure(as % of GDP) in Fiji per year?
Ensure brevity in your answer.  5.33. What is the average Expenditure(as % of GDP) in Kyrgyz Republic per year?
Your answer should be very brief. 4.95. What is the average Expenditure(as % of GDP) in Senegal per year?
Provide a short and direct response. 4.27. What is the average Expenditure(as % of GDP) of United States per year?
Ensure brevity in your answer.  5.25. In the year 1999, what is the difference between the Expenditure(as % of GDP) of Fiji and Expenditure(as % of GDP) of Kyrgyz Republic?
Keep it short and to the point. 1.07. In the year 1999, what is the difference between the Expenditure(as % of GDP) in Fiji and Expenditure(as % of GDP) in Senegal?
Give a very brief answer. 2. In the year 1999, what is the difference between the Expenditure(as % of GDP) of Fiji and Expenditure(as % of GDP) of United States?
Provide a short and direct response. 0.3. In the year 1999, what is the difference between the Expenditure(as % of GDP) in Kyrgyz Republic and Expenditure(as % of GDP) in Senegal?
Offer a very short reply. 0.93. In the year 1999, what is the difference between the Expenditure(as % of GDP) in Kyrgyz Republic and Expenditure(as % of GDP) in United States?
Your answer should be compact. -0.76. In the year 1999, what is the difference between the Expenditure(as % of GDP) in Senegal and Expenditure(as % of GDP) in United States?
Your answer should be very brief. -1.7. In the year 2001, what is the difference between the Expenditure(as % of GDP) of Fiji and Expenditure(as % of GDP) of Kyrgyz Republic?
Keep it short and to the point. 1.76. In the year 2001, what is the difference between the Expenditure(as % of GDP) of Fiji and Expenditure(as % of GDP) of Senegal?
Your answer should be very brief. 2.32. In the year 2001, what is the difference between the Expenditure(as % of GDP) in Fiji and Expenditure(as % of GDP) in United States?
Offer a very short reply. 0.16. In the year 2001, what is the difference between the Expenditure(as % of GDP) of Kyrgyz Republic and Expenditure(as % of GDP) of Senegal?
Keep it short and to the point. 0.56. In the year 2001, what is the difference between the Expenditure(as % of GDP) in Kyrgyz Republic and Expenditure(as % of GDP) in United States?
Your answer should be compact. -1.6. In the year 2001, what is the difference between the Expenditure(as % of GDP) of Senegal and Expenditure(as % of GDP) of United States?
Provide a succinct answer. -2.16. In the year 2002, what is the difference between the Expenditure(as % of GDP) in Fiji and Expenditure(as % of GDP) in Kyrgyz Republic?
Ensure brevity in your answer.  1.8. In the year 2002, what is the difference between the Expenditure(as % of GDP) in Fiji and Expenditure(as % of GDP) in Senegal?
Your response must be concise. 2.85. In the year 2002, what is the difference between the Expenditure(as % of GDP) of Fiji and Expenditure(as % of GDP) of United States?
Offer a terse response. 0.84. In the year 2002, what is the difference between the Expenditure(as % of GDP) in Kyrgyz Republic and Expenditure(as % of GDP) in Senegal?
Your answer should be very brief. 1.05. In the year 2002, what is the difference between the Expenditure(as % of GDP) of Kyrgyz Republic and Expenditure(as % of GDP) of United States?
Give a very brief answer. -0.96. In the year 2002, what is the difference between the Expenditure(as % of GDP) in Senegal and Expenditure(as % of GDP) in United States?
Give a very brief answer. -2.01. In the year 2004, what is the difference between the Expenditure(as % of GDP) of Fiji and Expenditure(as % of GDP) of Kyrgyz Republic?
Give a very brief answer. 1.54. In the year 2004, what is the difference between the Expenditure(as % of GDP) of Fiji and Expenditure(as % of GDP) of Senegal?
Your answer should be very brief. 2.31. In the year 2004, what is the difference between the Expenditure(as % of GDP) in Fiji and Expenditure(as % of GDP) in United States?
Ensure brevity in your answer.  0.86. In the year 2004, what is the difference between the Expenditure(as % of GDP) of Kyrgyz Republic and Expenditure(as % of GDP) of Senegal?
Make the answer very short. 0.77. In the year 2004, what is the difference between the Expenditure(as % of GDP) in Kyrgyz Republic and Expenditure(as % of GDP) in United States?
Ensure brevity in your answer.  -0.69. In the year 2004, what is the difference between the Expenditure(as % of GDP) of Senegal and Expenditure(as % of GDP) of United States?
Ensure brevity in your answer.  -1.45. In the year 2005, what is the difference between the Expenditure(as % of GDP) in Fiji and Expenditure(as % of GDP) in Kyrgyz Republic?
Make the answer very short. 0.25. In the year 2005, what is the difference between the Expenditure(as % of GDP) in Fiji and Expenditure(as % of GDP) in Senegal?
Offer a very short reply. -0.01. In the year 2005, what is the difference between the Expenditure(as % of GDP) in Fiji and Expenditure(as % of GDP) in United States?
Offer a very short reply. 0.05. In the year 2005, what is the difference between the Expenditure(as % of GDP) in Kyrgyz Republic and Expenditure(as % of GDP) in Senegal?
Your answer should be compact. -0.26. In the year 2005, what is the difference between the Expenditure(as % of GDP) in Kyrgyz Republic and Expenditure(as % of GDP) in United States?
Your response must be concise. -0.2. In the year 2005, what is the difference between the Expenditure(as % of GDP) in Senegal and Expenditure(as % of GDP) in United States?
Your response must be concise. 0.06. In the year 2006, what is the difference between the Expenditure(as % of GDP) in Fiji and Expenditure(as % of GDP) in Kyrgyz Republic?
Provide a succinct answer. 0.06. In the year 2006, what is the difference between the Expenditure(as % of GDP) of Fiji and Expenditure(as % of GDP) of Senegal?
Offer a terse response. 0.83. In the year 2006, what is the difference between the Expenditure(as % of GDP) of Fiji and Expenditure(as % of GDP) of United States?
Provide a short and direct response. 0.22. In the year 2006, what is the difference between the Expenditure(as % of GDP) in Kyrgyz Republic and Expenditure(as % of GDP) in Senegal?
Ensure brevity in your answer.  0.78. In the year 2006, what is the difference between the Expenditure(as % of GDP) in Kyrgyz Republic and Expenditure(as % of GDP) in United States?
Offer a very short reply. 0.16. In the year 2006, what is the difference between the Expenditure(as % of GDP) in Senegal and Expenditure(as % of GDP) in United States?
Provide a short and direct response. -0.62. In the year 2008, what is the difference between the Expenditure(as % of GDP) of Fiji and Expenditure(as % of GDP) of Kyrgyz Republic?
Provide a succinct answer. -1.66. In the year 2008, what is the difference between the Expenditure(as % of GDP) of Fiji and Expenditure(as % of GDP) of Senegal?
Provide a short and direct response. -0.79. In the year 2008, what is the difference between the Expenditure(as % of GDP) in Fiji and Expenditure(as % of GDP) in United States?
Provide a short and direct response. -1.05. In the year 2008, what is the difference between the Expenditure(as % of GDP) of Kyrgyz Republic and Expenditure(as % of GDP) of Senegal?
Provide a succinct answer. 0.87. In the year 2008, what is the difference between the Expenditure(as % of GDP) in Kyrgyz Republic and Expenditure(as % of GDP) in United States?
Provide a succinct answer. 0.61. In the year 2008, what is the difference between the Expenditure(as % of GDP) of Senegal and Expenditure(as % of GDP) of United States?
Offer a terse response. -0.26. In the year 2009, what is the difference between the Expenditure(as % of GDP) of Fiji and Expenditure(as % of GDP) of Kyrgyz Republic?
Provide a short and direct response. -1.73. In the year 2009, what is the difference between the Expenditure(as % of GDP) in Fiji and Expenditure(as % of GDP) in Senegal?
Give a very brief answer. -1.04. In the year 2009, what is the difference between the Expenditure(as % of GDP) of Fiji and Expenditure(as % of GDP) of United States?
Your response must be concise. -0.75. In the year 2009, what is the difference between the Expenditure(as % of GDP) in Kyrgyz Republic and Expenditure(as % of GDP) in Senegal?
Keep it short and to the point. 0.7. In the year 2009, what is the difference between the Expenditure(as % of GDP) in Kyrgyz Republic and Expenditure(as % of GDP) in United States?
Your answer should be very brief. 0.98. In the year 2009, what is the difference between the Expenditure(as % of GDP) of Senegal and Expenditure(as % of GDP) of United States?
Provide a succinct answer. 0.28. What is the ratio of the Expenditure(as % of GDP) of Fiji in 1999 to that in 2001?
Offer a terse response. 0.92. What is the ratio of the Expenditure(as % of GDP) of Kyrgyz Republic in 1999 to that in 2001?
Provide a short and direct response. 1.06. What is the ratio of the Expenditure(as % of GDP) of Senegal in 1999 to that in 2001?
Give a very brief answer. 0.96. What is the ratio of the Expenditure(as % of GDP) of United States in 1999 to that in 2001?
Give a very brief answer. 0.89. What is the ratio of the Expenditure(as % of GDP) of Fiji in 1999 to that in 2002?
Your answer should be very brief. 0.83. What is the ratio of the Expenditure(as % of GDP) in Kyrgyz Republic in 1999 to that in 2002?
Your answer should be compact. 0.92. What is the ratio of the Expenditure(as % of GDP) of Senegal in 1999 to that in 2002?
Make the answer very short. 0.93. What is the ratio of the Expenditure(as % of GDP) of United States in 1999 to that in 2002?
Your answer should be very brief. 0.9. What is the ratio of the Expenditure(as % of GDP) of Fiji in 1999 to that in 2004?
Your answer should be compact. 0.84. What is the ratio of the Expenditure(as % of GDP) of Kyrgyz Republic in 1999 to that in 2004?
Your answer should be compact. 0.88. What is the ratio of the Expenditure(as % of GDP) of Senegal in 1999 to that in 2004?
Provide a succinct answer. 0.82. What is the ratio of the Expenditure(as % of GDP) in United States in 1999 to that in 2004?
Provide a succinct answer. 0.91. What is the ratio of the Expenditure(as % of GDP) of Kyrgyz Republic in 1999 to that in 2005?
Keep it short and to the point. 0.84. What is the ratio of the Expenditure(as % of GDP) in Senegal in 1999 to that in 2005?
Offer a very short reply. 0.61. What is the ratio of the Expenditure(as % of GDP) in United States in 1999 to that in 2005?
Your answer should be compact. 0.96. What is the ratio of the Expenditure(as % of GDP) in Fiji in 1999 to that in 2006?
Your response must be concise. 0.92. What is the ratio of the Expenditure(as % of GDP) in Kyrgyz Republic in 1999 to that in 2006?
Provide a succinct answer. 0.74. What is the ratio of the Expenditure(as % of GDP) of Senegal in 1999 to that in 2006?
Offer a very short reply. 0.66. What is the ratio of the Expenditure(as % of GDP) of United States in 1999 to that in 2006?
Offer a terse response. 0.9. What is the ratio of the Expenditure(as % of GDP) of Fiji in 1999 to that in 2008?
Provide a succinct answer. 1.21. What is the ratio of the Expenditure(as % of GDP) in Kyrgyz Republic in 1999 to that in 2008?
Make the answer very short. 0.69. What is the ratio of the Expenditure(as % of GDP) in Senegal in 1999 to that in 2008?
Offer a terse response. 0.62. What is the ratio of the Expenditure(as % of GDP) in United States in 1999 to that in 2008?
Give a very brief answer. 0.91. What is the ratio of the Expenditure(as % of GDP) of Fiji in 1999 to that in 2009?
Ensure brevity in your answer.  1.15. What is the ratio of the Expenditure(as % of GDP) of Kyrgyz Republic in 1999 to that in 2009?
Provide a succinct answer. 0.66. What is the ratio of the Expenditure(as % of GDP) of Senegal in 1999 to that in 2009?
Your answer should be very brief. 0.57. What is the ratio of the Expenditure(as % of GDP) in United States in 1999 to that in 2009?
Your response must be concise. 0.92. What is the ratio of the Expenditure(as % of GDP) in Fiji in 2001 to that in 2002?
Provide a succinct answer. 0.9. What is the ratio of the Expenditure(as % of GDP) in Kyrgyz Republic in 2001 to that in 2002?
Offer a very short reply. 0.87. What is the ratio of the Expenditure(as % of GDP) in Senegal in 2001 to that in 2002?
Make the answer very short. 0.97. What is the ratio of the Expenditure(as % of GDP) in United States in 2001 to that in 2002?
Your answer should be compact. 1.01. What is the ratio of the Expenditure(as % of GDP) in Fiji in 2001 to that in 2004?
Your answer should be compact. 0.91. What is the ratio of the Expenditure(as % of GDP) in Kyrgyz Republic in 2001 to that in 2004?
Your answer should be very brief. 0.83. What is the ratio of the Expenditure(as % of GDP) of Senegal in 2001 to that in 2004?
Ensure brevity in your answer.  0.85. What is the ratio of the Expenditure(as % of GDP) of United States in 2001 to that in 2004?
Ensure brevity in your answer.  1.03. What is the ratio of the Expenditure(as % of GDP) in Fiji in 2001 to that in 2005?
Your answer should be very brief. 1.1. What is the ratio of the Expenditure(as % of GDP) of Kyrgyz Republic in 2001 to that in 2005?
Offer a terse response. 0.79. What is the ratio of the Expenditure(as % of GDP) in Senegal in 2001 to that in 2005?
Your response must be concise. 0.64. What is the ratio of the Expenditure(as % of GDP) in United States in 2001 to that in 2005?
Your response must be concise. 1.08. What is the ratio of the Expenditure(as % of GDP) of Fiji in 2001 to that in 2006?
Offer a terse response. 1. What is the ratio of the Expenditure(as % of GDP) in Kyrgyz Republic in 2001 to that in 2006?
Offer a terse response. 0.69. What is the ratio of the Expenditure(as % of GDP) in Senegal in 2001 to that in 2006?
Your answer should be very brief. 0.69. What is the ratio of the Expenditure(as % of GDP) of United States in 2001 to that in 2006?
Your answer should be compact. 1.01. What is the ratio of the Expenditure(as % of GDP) in Fiji in 2001 to that in 2008?
Offer a very short reply. 1.32. What is the ratio of the Expenditure(as % of GDP) of Kyrgyz Republic in 2001 to that in 2008?
Your answer should be very brief. 0.65. What is the ratio of the Expenditure(as % of GDP) in Senegal in 2001 to that in 2008?
Your answer should be compact. 0.65. What is the ratio of the Expenditure(as % of GDP) in United States in 2001 to that in 2008?
Provide a succinct answer. 1.03. What is the ratio of the Expenditure(as % of GDP) in Fiji in 2001 to that in 2009?
Your answer should be compact. 1.25. What is the ratio of the Expenditure(as % of GDP) in Kyrgyz Republic in 2001 to that in 2009?
Offer a very short reply. 0.62. What is the ratio of the Expenditure(as % of GDP) of Senegal in 2001 to that in 2009?
Offer a terse response. 0.6. What is the ratio of the Expenditure(as % of GDP) in United States in 2001 to that in 2009?
Give a very brief answer. 1.04. What is the ratio of the Expenditure(as % of GDP) in Fiji in 2002 to that in 2004?
Give a very brief answer. 1.01. What is the ratio of the Expenditure(as % of GDP) in Kyrgyz Republic in 2002 to that in 2004?
Your response must be concise. 0.96. What is the ratio of the Expenditure(as % of GDP) of Senegal in 2002 to that in 2004?
Offer a very short reply. 0.88. What is the ratio of the Expenditure(as % of GDP) of United States in 2002 to that in 2004?
Provide a short and direct response. 1.02. What is the ratio of the Expenditure(as % of GDP) of Fiji in 2002 to that in 2005?
Your answer should be very brief. 1.22. What is the ratio of the Expenditure(as % of GDP) of Kyrgyz Republic in 2002 to that in 2005?
Offer a terse response. 0.91. What is the ratio of the Expenditure(as % of GDP) of Senegal in 2002 to that in 2005?
Give a very brief answer. 0.66. What is the ratio of the Expenditure(as % of GDP) of United States in 2002 to that in 2005?
Your answer should be compact. 1.07. What is the ratio of the Expenditure(as % of GDP) in Fiji in 2002 to that in 2006?
Offer a terse response. 1.11. What is the ratio of the Expenditure(as % of GDP) of Kyrgyz Republic in 2002 to that in 2006?
Offer a terse response. 0.8. What is the ratio of the Expenditure(as % of GDP) of Senegal in 2002 to that in 2006?
Your answer should be compact. 0.71. What is the ratio of the Expenditure(as % of GDP) of Fiji in 2002 to that in 2008?
Ensure brevity in your answer.  1.47. What is the ratio of the Expenditure(as % of GDP) in Kyrgyz Republic in 2002 to that in 2008?
Your answer should be compact. 0.75. What is the ratio of the Expenditure(as % of GDP) in Senegal in 2002 to that in 2008?
Your answer should be very brief. 0.67. What is the ratio of the Expenditure(as % of GDP) of United States in 2002 to that in 2008?
Provide a succinct answer. 1.02. What is the ratio of the Expenditure(as % of GDP) in Fiji in 2002 to that in 2009?
Your answer should be very brief. 1.39. What is the ratio of the Expenditure(as % of GDP) in Kyrgyz Republic in 2002 to that in 2009?
Your answer should be very brief. 0.71. What is the ratio of the Expenditure(as % of GDP) in Senegal in 2002 to that in 2009?
Ensure brevity in your answer.  0.61. What is the ratio of the Expenditure(as % of GDP) of United States in 2002 to that in 2009?
Keep it short and to the point. 1.03. What is the ratio of the Expenditure(as % of GDP) in Fiji in 2004 to that in 2005?
Ensure brevity in your answer.  1.2. What is the ratio of the Expenditure(as % of GDP) in Kyrgyz Republic in 2004 to that in 2005?
Provide a succinct answer. 0.95. What is the ratio of the Expenditure(as % of GDP) in Senegal in 2004 to that in 2005?
Provide a short and direct response. 0.75. What is the ratio of the Expenditure(as % of GDP) in United States in 2004 to that in 2005?
Your answer should be very brief. 1.05. What is the ratio of the Expenditure(as % of GDP) of Fiji in 2004 to that in 2006?
Offer a very short reply. 1.1. What is the ratio of the Expenditure(as % of GDP) in Kyrgyz Republic in 2004 to that in 2006?
Offer a very short reply. 0.83. What is the ratio of the Expenditure(as % of GDP) of Senegal in 2004 to that in 2006?
Keep it short and to the point. 0.81. What is the ratio of the Expenditure(as % of GDP) of United States in 2004 to that in 2006?
Your response must be concise. 0.99. What is the ratio of the Expenditure(as % of GDP) of Fiji in 2004 to that in 2008?
Provide a succinct answer. 1.45. What is the ratio of the Expenditure(as % of GDP) in Kyrgyz Republic in 2004 to that in 2008?
Keep it short and to the point. 0.78. What is the ratio of the Expenditure(as % of GDP) in Senegal in 2004 to that in 2008?
Offer a very short reply. 0.76. What is the ratio of the Expenditure(as % of GDP) in United States in 2004 to that in 2008?
Offer a very short reply. 1. What is the ratio of the Expenditure(as % of GDP) of Fiji in 2004 to that in 2009?
Your answer should be compact. 1.37. What is the ratio of the Expenditure(as % of GDP) of Kyrgyz Republic in 2004 to that in 2009?
Offer a terse response. 0.74. What is the ratio of the Expenditure(as % of GDP) in Senegal in 2004 to that in 2009?
Offer a terse response. 0.7. What is the ratio of the Expenditure(as % of GDP) in United States in 2004 to that in 2009?
Your answer should be compact. 1.01. What is the ratio of the Expenditure(as % of GDP) in Fiji in 2005 to that in 2006?
Provide a succinct answer. 0.91. What is the ratio of the Expenditure(as % of GDP) of Kyrgyz Republic in 2005 to that in 2006?
Your response must be concise. 0.88. What is the ratio of the Expenditure(as % of GDP) in Senegal in 2005 to that in 2006?
Offer a terse response. 1.08. What is the ratio of the Expenditure(as % of GDP) in United States in 2005 to that in 2006?
Keep it short and to the point. 0.94. What is the ratio of the Expenditure(as % of GDP) in Fiji in 2005 to that in 2008?
Give a very brief answer. 1.2. What is the ratio of the Expenditure(as % of GDP) in Kyrgyz Republic in 2005 to that in 2008?
Give a very brief answer. 0.82. What is the ratio of the Expenditure(as % of GDP) in Senegal in 2005 to that in 2008?
Offer a very short reply. 1.02. What is the ratio of the Expenditure(as % of GDP) of United States in 2005 to that in 2008?
Ensure brevity in your answer.  0.96. What is the ratio of the Expenditure(as % of GDP) of Fiji in 2005 to that in 2009?
Provide a succinct answer. 1.14. What is the ratio of the Expenditure(as % of GDP) in Kyrgyz Republic in 2005 to that in 2009?
Give a very brief answer. 0.78. What is the ratio of the Expenditure(as % of GDP) of Senegal in 2005 to that in 2009?
Ensure brevity in your answer.  0.93. What is the ratio of the Expenditure(as % of GDP) in United States in 2005 to that in 2009?
Your answer should be very brief. 0.97. What is the ratio of the Expenditure(as % of GDP) in Fiji in 2006 to that in 2008?
Offer a terse response. 1.32. What is the ratio of the Expenditure(as % of GDP) in Kyrgyz Republic in 2006 to that in 2008?
Make the answer very short. 0.94. What is the ratio of the Expenditure(as % of GDP) in Senegal in 2006 to that in 2008?
Your response must be concise. 0.95. What is the ratio of the Expenditure(as % of GDP) of United States in 2006 to that in 2008?
Provide a succinct answer. 1.02. What is the ratio of the Expenditure(as % of GDP) in Fiji in 2006 to that in 2009?
Your answer should be compact. 1.25. What is the ratio of the Expenditure(as % of GDP) of Kyrgyz Republic in 2006 to that in 2009?
Make the answer very short. 0.89. What is the ratio of the Expenditure(as % of GDP) of Senegal in 2006 to that in 2009?
Your response must be concise. 0.86. What is the ratio of the Expenditure(as % of GDP) of United States in 2006 to that in 2009?
Ensure brevity in your answer.  1.03. What is the ratio of the Expenditure(as % of GDP) in Fiji in 2008 to that in 2009?
Provide a short and direct response. 0.95. What is the ratio of the Expenditure(as % of GDP) of Kyrgyz Republic in 2008 to that in 2009?
Provide a succinct answer. 0.95. What is the ratio of the Expenditure(as % of GDP) of Senegal in 2008 to that in 2009?
Give a very brief answer. 0.91. What is the ratio of the Expenditure(as % of GDP) in United States in 2008 to that in 2009?
Offer a very short reply. 1.01. What is the difference between the highest and the second highest Expenditure(as % of GDP) of Fiji?
Provide a short and direct response. 0.08. What is the difference between the highest and the second highest Expenditure(as % of GDP) of Kyrgyz Republic?
Provide a succinct answer. 0.32. What is the difference between the highest and the second highest Expenditure(as % of GDP) in Senegal?
Your answer should be compact. 0.4. What is the difference between the highest and the second highest Expenditure(as % of GDP) in United States?
Your answer should be very brief. 0.05. What is the difference between the highest and the lowest Expenditure(as % of GDP) of Fiji?
Provide a succinct answer. 1.99. What is the difference between the highest and the lowest Expenditure(as % of GDP) in Kyrgyz Republic?
Provide a succinct answer. 2.38. What is the difference between the highest and the lowest Expenditure(as % of GDP) of Senegal?
Your answer should be very brief. 2.38. What is the difference between the highest and the lowest Expenditure(as % of GDP) in United States?
Your response must be concise. 0.61. 